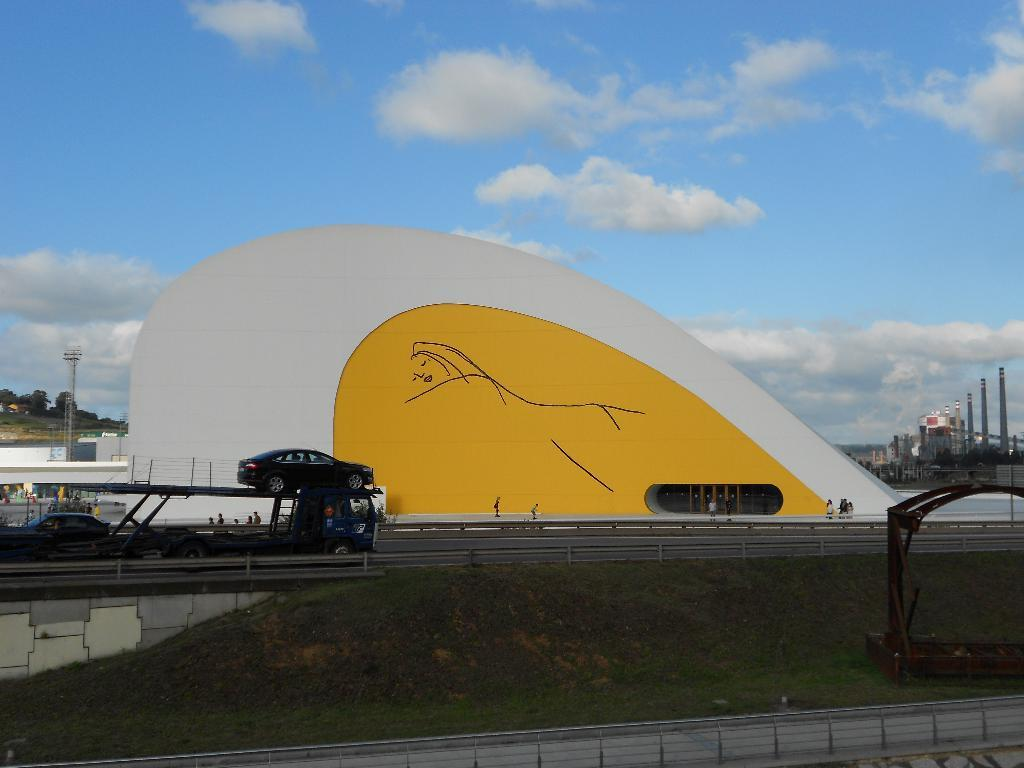What types of objects can be seen in the image? There are vehicles, trees, people, poles, grass, a fence, and a wall in the image. What is on the ground in the image? There is an object on the ground in the image. What can be seen in the background of the image? The sky is visible in the background of the image, and there are clouds in the sky. What type of knowledge is being shared during the dinner in the image? There is no dinner or knowledge sharing present in the image. Can you describe the cat's behavior in the image? There is no cat present in the image. 